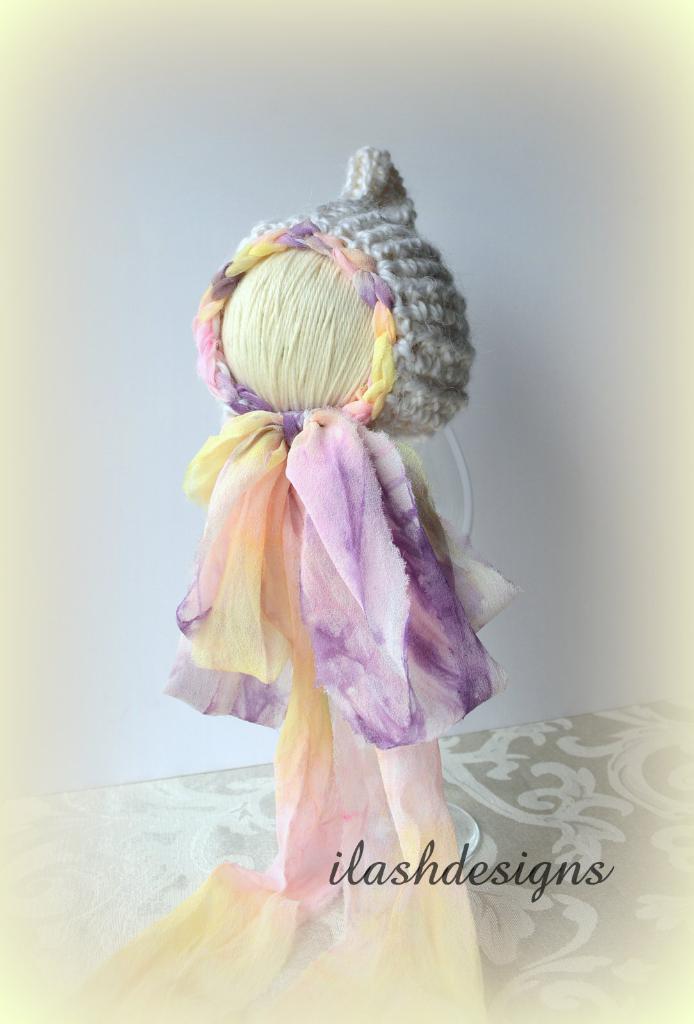Describe this image in one or two sentences. This is a handicraft made with threads and clothes. Also there is a watermark on that. In the background there is wall. 